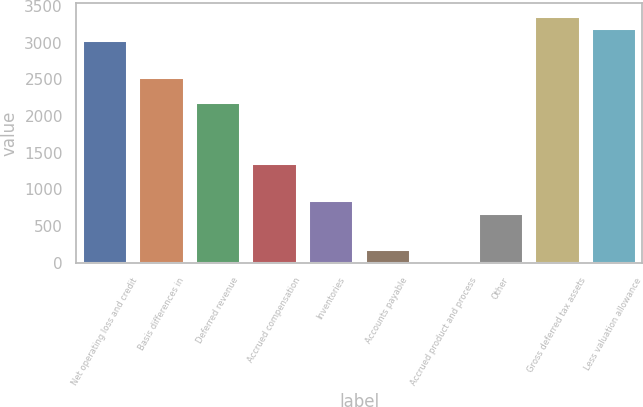Convert chart. <chart><loc_0><loc_0><loc_500><loc_500><bar_chart><fcel>Net operating loss and credit<fcel>Basis differences in<fcel>Deferred revenue<fcel>Accrued compensation<fcel>Inventories<fcel>Accounts payable<fcel>Accrued product and process<fcel>Other<fcel>Gross deferred tax assets<fcel>Less valuation allowance<nl><fcel>3034.4<fcel>2531<fcel>2195.4<fcel>1356.4<fcel>853<fcel>181.8<fcel>14<fcel>685.2<fcel>3370<fcel>3202.2<nl></chart> 